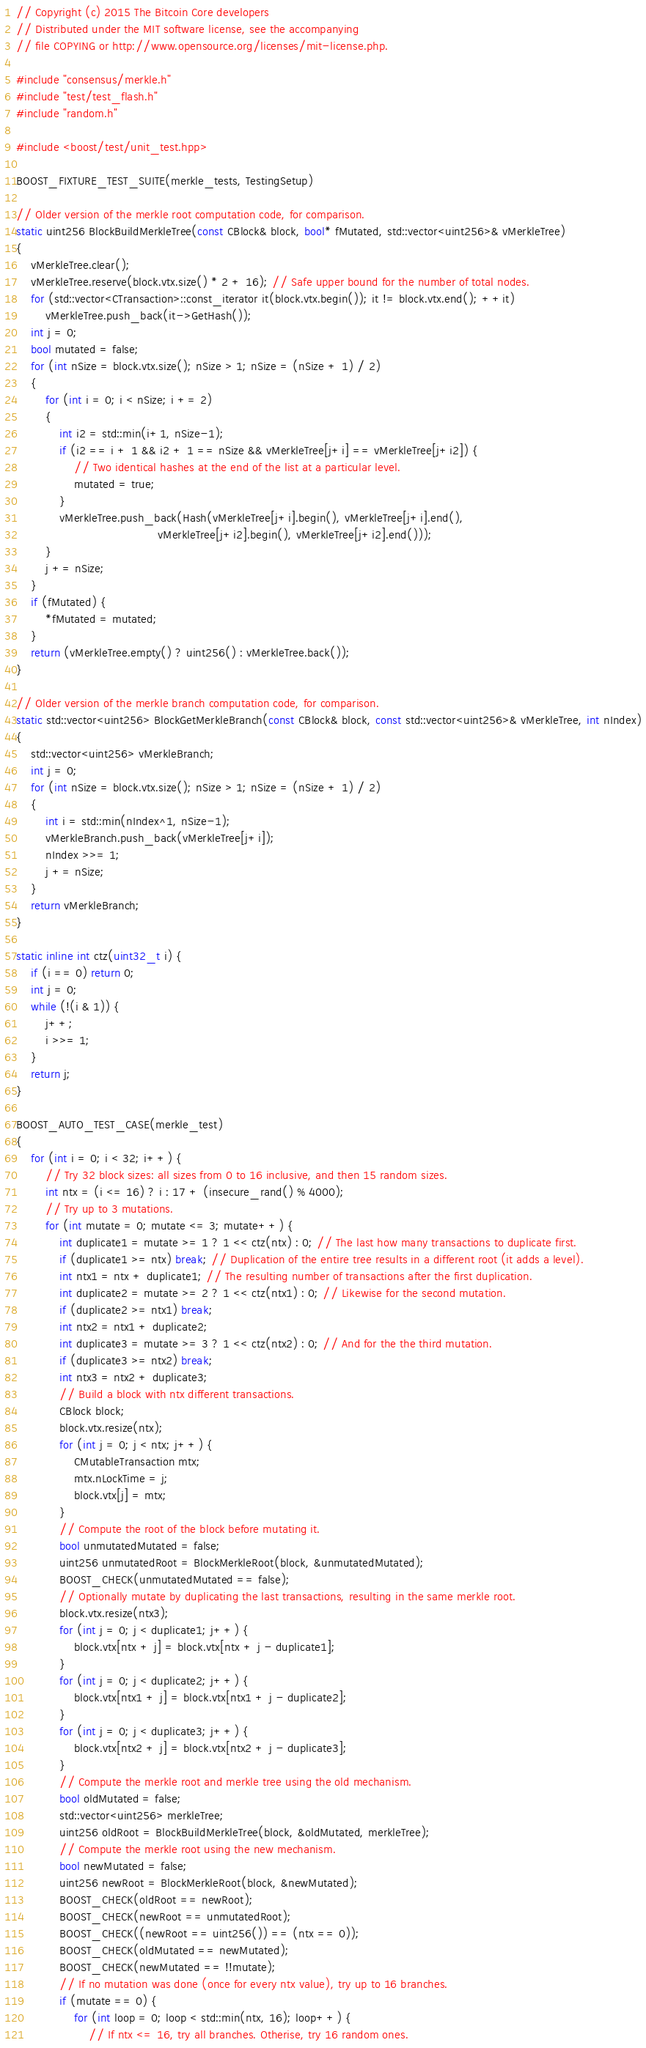<code> <loc_0><loc_0><loc_500><loc_500><_C++_>// Copyright (c) 2015 The Bitcoin Core developers
// Distributed under the MIT software license, see the accompanying
// file COPYING or http://www.opensource.org/licenses/mit-license.php.

#include "consensus/merkle.h"
#include "test/test_flash.h"
#include "random.h"

#include <boost/test/unit_test.hpp>

BOOST_FIXTURE_TEST_SUITE(merkle_tests, TestingSetup)

// Older version of the merkle root computation code, for comparison.
static uint256 BlockBuildMerkleTree(const CBlock& block, bool* fMutated, std::vector<uint256>& vMerkleTree)
{
    vMerkleTree.clear();
    vMerkleTree.reserve(block.vtx.size() * 2 + 16); // Safe upper bound for the number of total nodes.
    for (std::vector<CTransaction>::const_iterator it(block.vtx.begin()); it != block.vtx.end(); ++it)
        vMerkleTree.push_back(it->GetHash());
    int j = 0;
    bool mutated = false;
    for (int nSize = block.vtx.size(); nSize > 1; nSize = (nSize + 1) / 2)
    {
        for (int i = 0; i < nSize; i += 2)
        {
            int i2 = std::min(i+1, nSize-1);
            if (i2 == i + 1 && i2 + 1 == nSize && vMerkleTree[j+i] == vMerkleTree[j+i2]) {
                // Two identical hashes at the end of the list at a particular level.
                mutated = true;
            }
            vMerkleTree.push_back(Hash(vMerkleTree[j+i].begin(), vMerkleTree[j+i].end(),
                                       vMerkleTree[j+i2].begin(), vMerkleTree[j+i2].end()));
        }
        j += nSize;
    }
    if (fMutated) {
        *fMutated = mutated;
    }
    return (vMerkleTree.empty() ? uint256() : vMerkleTree.back());
}

// Older version of the merkle branch computation code, for comparison.
static std::vector<uint256> BlockGetMerkleBranch(const CBlock& block, const std::vector<uint256>& vMerkleTree, int nIndex)
{
    std::vector<uint256> vMerkleBranch;
    int j = 0;
    for (int nSize = block.vtx.size(); nSize > 1; nSize = (nSize + 1) / 2)
    {
        int i = std::min(nIndex^1, nSize-1);
        vMerkleBranch.push_back(vMerkleTree[j+i]);
        nIndex >>= 1;
        j += nSize;
    }
    return vMerkleBranch;
}

static inline int ctz(uint32_t i) {
    if (i == 0) return 0;
    int j = 0;
    while (!(i & 1)) {
        j++;
        i >>= 1;
    }
    return j;
}

BOOST_AUTO_TEST_CASE(merkle_test)
{
    for (int i = 0; i < 32; i++) {
        // Try 32 block sizes: all sizes from 0 to 16 inclusive, and then 15 random sizes.
        int ntx = (i <= 16) ? i : 17 + (insecure_rand() % 4000);
        // Try up to 3 mutations.
        for (int mutate = 0; mutate <= 3; mutate++) {
            int duplicate1 = mutate >= 1 ? 1 << ctz(ntx) : 0; // The last how many transactions to duplicate first.
            if (duplicate1 >= ntx) break; // Duplication of the entire tree results in a different root (it adds a level).
            int ntx1 = ntx + duplicate1; // The resulting number of transactions after the first duplication.
            int duplicate2 = mutate >= 2 ? 1 << ctz(ntx1) : 0; // Likewise for the second mutation.
            if (duplicate2 >= ntx1) break;
            int ntx2 = ntx1 + duplicate2;
            int duplicate3 = mutate >= 3 ? 1 << ctz(ntx2) : 0; // And for the the third mutation.
            if (duplicate3 >= ntx2) break;
            int ntx3 = ntx2 + duplicate3;
            // Build a block with ntx different transactions.
            CBlock block;
            block.vtx.resize(ntx);
            for (int j = 0; j < ntx; j++) {
                CMutableTransaction mtx;
                mtx.nLockTime = j;
                block.vtx[j] = mtx;
            }
            // Compute the root of the block before mutating it.
            bool unmutatedMutated = false;
            uint256 unmutatedRoot = BlockMerkleRoot(block, &unmutatedMutated);
            BOOST_CHECK(unmutatedMutated == false);
            // Optionally mutate by duplicating the last transactions, resulting in the same merkle root.
            block.vtx.resize(ntx3);
            for (int j = 0; j < duplicate1; j++) {
                block.vtx[ntx + j] = block.vtx[ntx + j - duplicate1];
            }
            for (int j = 0; j < duplicate2; j++) {
                block.vtx[ntx1 + j] = block.vtx[ntx1 + j - duplicate2];
            }
            for (int j = 0; j < duplicate3; j++) {
                block.vtx[ntx2 + j] = block.vtx[ntx2 + j - duplicate3];
            }
            // Compute the merkle root and merkle tree using the old mechanism.
            bool oldMutated = false;
            std::vector<uint256> merkleTree;
            uint256 oldRoot = BlockBuildMerkleTree(block, &oldMutated, merkleTree);
            // Compute the merkle root using the new mechanism.
            bool newMutated = false;
            uint256 newRoot = BlockMerkleRoot(block, &newMutated);
            BOOST_CHECK(oldRoot == newRoot);
            BOOST_CHECK(newRoot == unmutatedRoot);
            BOOST_CHECK((newRoot == uint256()) == (ntx == 0));
            BOOST_CHECK(oldMutated == newMutated);
            BOOST_CHECK(newMutated == !!mutate);
            // If no mutation was done (once for every ntx value), try up to 16 branches.
            if (mutate == 0) {
                for (int loop = 0; loop < std::min(ntx, 16); loop++) {
                    // If ntx <= 16, try all branches. Otherise, try 16 random ones.</code> 